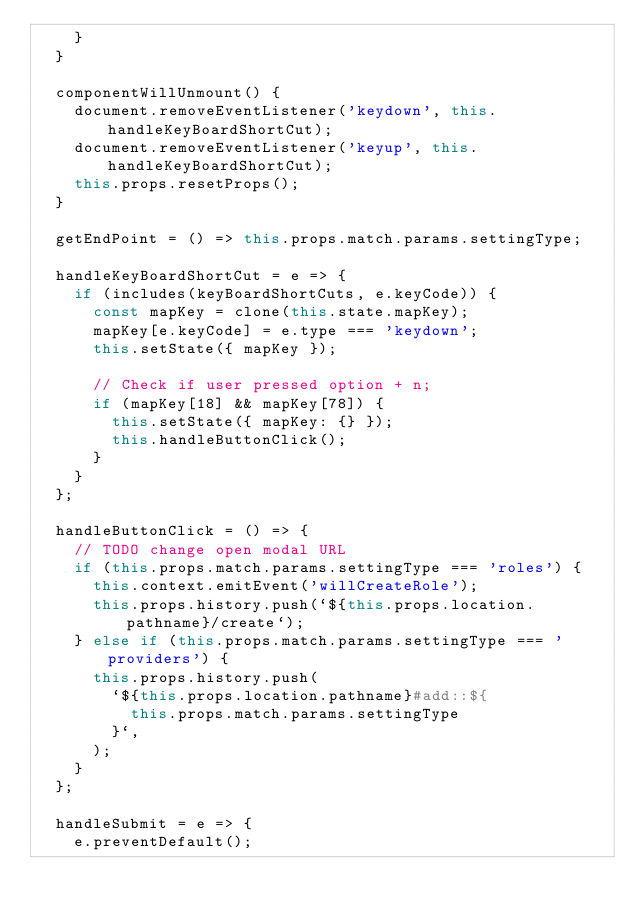Convert code to text. <code><loc_0><loc_0><loc_500><loc_500><_JavaScript_>    }
  }

  componentWillUnmount() {
    document.removeEventListener('keydown', this.handleKeyBoardShortCut);
    document.removeEventListener('keyup', this.handleKeyBoardShortCut);
    this.props.resetProps();
  }

  getEndPoint = () => this.props.match.params.settingType;

  handleKeyBoardShortCut = e => {
    if (includes(keyBoardShortCuts, e.keyCode)) {
      const mapKey = clone(this.state.mapKey);
      mapKey[e.keyCode] = e.type === 'keydown';
      this.setState({ mapKey });

      // Check if user pressed option + n;
      if (mapKey[18] && mapKey[78]) {
        this.setState({ mapKey: {} });
        this.handleButtonClick();
      }
    }
  };

  handleButtonClick = () => {
    // TODO change open modal URL
    if (this.props.match.params.settingType === 'roles') {
      this.context.emitEvent('willCreateRole');
      this.props.history.push(`${this.props.location.pathname}/create`);
    } else if (this.props.match.params.settingType === 'providers') {
      this.props.history.push(
        `${this.props.location.pathname}#add::${
          this.props.match.params.settingType
        }`,
      );
    }
  };

  handleSubmit = e => {
    e.preventDefault();</code> 